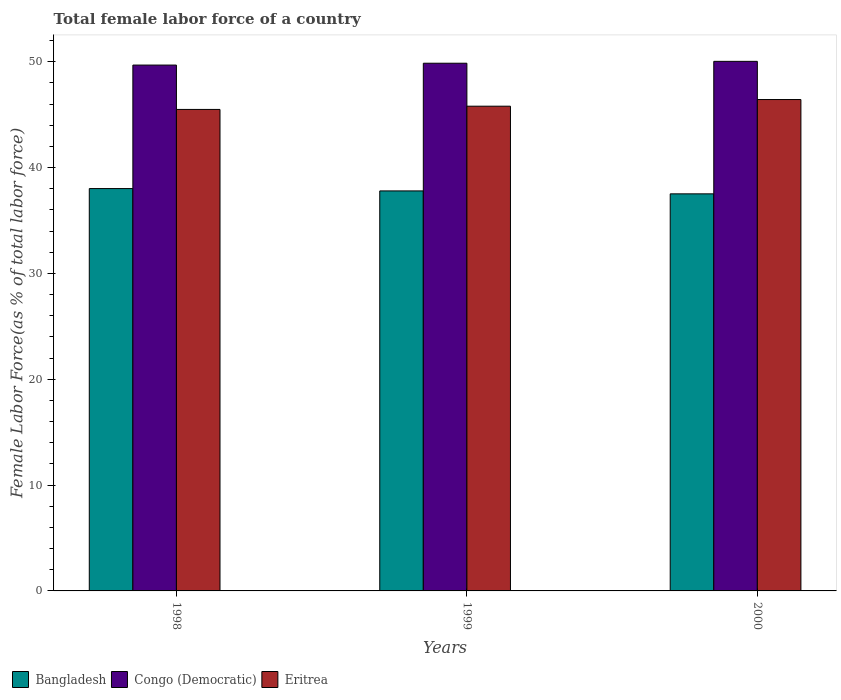How many different coloured bars are there?
Give a very brief answer. 3. How many groups of bars are there?
Give a very brief answer. 3. Are the number of bars on each tick of the X-axis equal?
Your response must be concise. Yes. How many bars are there on the 2nd tick from the right?
Provide a succinct answer. 3. What is the label of the 2nd group of bars from the left?
Provide a succinct answer. 1999. In how many cases, is the number of bars for a given year not equal to the number of legend labels?
Your answer should be compact. 0. What is the percentage of female labor force in Eritrea in 1999?
Your answer should be very brief. 45.81. Across all years, what is the maximum percentage of female labor force in Eritrea?
Offer a terse response. 46.44. Across all years, what is the minimum percentage of female labor force in Bangladesh?
Make the answer very short. 37.52. In which year was the percentage of female labor force in Bangladesh minimum?
Offer a terse response. 2000. What is the total percentage of female labor force in Bangladesh in the graph?
Your response must be concise. 113.35. What is the difference between the percentage of female labor force in Eritrea in 1998 and that in 1999?
Keep it short and to the point. -0.31. What is the difference between the percentage of female labor force in Congo (Democratic) in 1998 and the percentage of female labor force in Bangladesh in 1999?
Offer a very short reply. 11.89. What is the average percentage of female labor force in Bangladesh per year?
Your answer should be very brief. 37.78. In the year 2000, what is the difference between the percentage of female labor force in Congo (Democratic) and percentage of female labor force in Bangladesh?
Your answer should be compact. 12.52. What is the ratio of the percentage of female labor force in Bangladesh in 1998 to that in 2000?
Your answer should be very brief. 1.01. Is the difference between the percentage of female labor force in Congo (Democratic) in 1998 and 1999 greater than the difference between the percentage of female labor force in Bangladesh in 1998 and 1999?
Your answer should be compact. No. What is the difference between the highest and the second highest percentage of female labor force in Bangladesh?
Your response must be concise. 0.22. What is the difference between the highest and the lowest percentage of female labor force in Congo (Democratic)?
Ensure brevity in your answer.  0.35. Is it the case that in every year, the sum of the percentage of female labor force in Eritrea and percentage of female labor force in Bangladesh is greater than the percentage of female labor force in Congo (Democratic)?
Offer a terse response. Yes. How many bars are there?
Provide a short and direct response. 9. Are all the bars in the graph horizontal?
Offer a very short reply. No. How many years are there in the graph?
Ensure brevity in your answer.  3. What is the difference between two consecutive major ticks on the Y-axis?
Your answer should be compact. 10. Are the values on the major ticks of Y-axis written in scientific E-notation?
Your response must be concise. No. Does the graph contain grids?
Offer a very short reply. No. Where does the legend appear in the graph?
Your answer should be compact. Bottom left. What is the title of the graph?
Your response must be concise. Total female labor force of a country. What is the label or title of the Y-axis?
Offer a terse response. Female Labor Force(as % of total labor force). What is the Female Labor Force(as % of total labor force) in Bangladesh in 1998?
Ensure brevity in your answer.  38.02. What is the Female Labor Force(as % of total labor force) in Congo (Democratic) in 1998?
Ensure brevity in your answer.  49.69. What is the Female Labor Force(as % of total labor force) in Eritrea in 1998?
Your response must be concise. 45.5. What is the Female Labor Force(as % of total labor force) in Bangladesh in 1999?
Ensure brevity in your answer.  37.8. What is the Female Labor Force(as % of total labor force) of Congo (Democratic) in 1999?
Make the answer very short. 49.87. What is the Female Labor Force(as % of total labor force) in Eritrea in 1999?
Offer a very short reply. 45.81. What is the Female Labor Force(as % of total labor force) in Bangladesh in 2000?
Offer a terse response. 37.52. What is the Female Labor Force(as % of total labor force) in Congo (Democratic) in 2000?
Your answer should be compact. 50.05. What is the Female Labor Force(as % of total labor force) in Eritrea in 2000?
Give a very brief answer. 46.44. Across all years, what is the maximum Female Labor Force(as % of total labor force) of Bangladesh?
Ensure brevity in your answer.  38.02. Across all years, what is the maximum Female Labor Force(as % of total labor force) of Congo (Democratic)?
Your answer should be compact. 50.05. Across all years, what is the maximum Female Labor Force(as % of total labor force) of Eritrea?
Make the answer very short. 46.44. Across all years, what is the minimum Female Labor Force(as % of total labor force) in Bangladesh?
Make the answer very short. 37.52. Across all years, what is the minimum Female Labor Force(as % of total labor force) in Congo (Democratic)?
Provide a succinct answer. 49.69. Across all years, what is the minimum Female Labor Force(as % of total labor force) of Eritrea?
Provide a succinct answer. 45.5. What is the total Female Labor Force(as % of total labor force) in Bangladesh in the graph?
Provide a succinct answer. 113.35. What is the total Female Labor Force(as % of total labor force) of Congo (Democratic) in the graph?
Your answer should be very brief. 149.61. What is the total Female Labor Force(as % of total labor force) in Eritrea in the graph?
Make the answer very short. 137.75. What is the difference between the Female Labor Force(as % of total labor force) of Bangladesh in 1998 and that in 1999?
Your answer should be very brief. 0.22. What is the difference between the Female Labor Force(as % of total labor force) in Congo (Democratic) in 1998 and that in 1999?
Provide a succinct answer. -0.17. What is the difference between the Female Labor Force(as % of total labor force) of Eritrea in 1998 and that in 1999?
Offer a very short reply. -0.31. What is the difference between the Female Labor Force(as % of total labor force) in Bangladesh in 1998 and that in 2000?
Provide a succinct answer. 0.5. What is the difference between the Female Labor Force(as % of total labor force) of Congo (Democratic) in 1998 and that in 2000?
Offer a very short reply. -0.35. What is the difference between the Female Labor Force(as % of total labor force) in Eritrea in 1998 and that in 2000?
Your response must be concise. -0.94. What is the difference between the Female Labor Force(as % of total labor force) of Bangladesh in 1999 and that in 2000?
Make the answer very short. 0.28. What is the difference between the Female Labor Force(as % of total labor force) in Congo (Democratic) in 1999 and that in 2000?
Offer a very short reply. -0.18. What is the difference between the Female Labor Force(as % of total labor force) of Eritrea in 1999 and that in 2000?
Your answer should be very brief. -0.63. What is the difference between the Female Labor Force(as % of total labor force) in Bangladesh in 1998 and the Female Labor Force(as % of total labor force) in Congo (Democratic) in 1999?
Your answer should be compact. -11.85. What is the difference between the Female Labor Force(as % of total labor force) of Bangladesh in 1998 and the Female Labor Force(as % of total labor force) of Eritrea in 1999?
Ensure brevity in your answer.  -7.78. What is the difference between the Female Labor Force(as % of total labor force) in Congo (Democratic) in 1998 and the Female Labor Force(as % of total labor force) in Eritrea in 1999?
Ensure brevity in your answer.  3.89. What is the difference between the Female Labor Force(as % of total labor force) in Bangladesh in 1998 and the Female Labor Force(as % of total labor force) in Congo (Democratic) in 2000?
Your answer should be very brief. -12.02. What is the difference between the Female Labor Force(as % of total labor force) in Bangladesh in 1998 and the Female Labor Force(as % of total labor force) in Eritrea in 2000?
Ensure brevity in your answer.  -8.41. What is the difference between the Female Labor Force(as % of total labor force) of Congo (Democratic) in 1998 and the Female Labor Force(as % of total labor force) of Eritrea in 2000?
Give a very brief answer. 3.26. What is the difference between the Female Labor Force(as % of total labor force) in Bangladesh in 1999 and the Female Labor Force(as % of total labor force) in Congo (Democratic) in 2000?
Ensure brevity in your answer.  -12.24. What is the difference between the Female Labor Force(as % of total labor force) of Bangladesh in 1999 and the Female Labor Force(as % of total labor force) of Eritrea in 2000?
Your answer should be compact. -8.64. What is the difference between the Female Labor Force(as % of total labor force) in Congo (Democratic) in 1999 and the Female Labor Force(as % of total labor force) in Eritrea in 2000?
Ensure brevity in your answer.  3.43. What is the average Female Labor Force(as % of total labor force) of Bangladesh per year?
Provide a short and direct response. 37.78. What is the average Female Labor Force(as % of total labor force) in Congo (Democratic) per year?
Your answer should be compact. 49.87. What is the average Female Labor Force(as % of total labor force) of Eritrea per year?
Provide a succinct answer. 45.92. In the year 1998, what is the difference between the Female Labor Force(as % of total labor force) in Bangladesh and Female Labor Force(as % of total labor force) in Congo (Democratic)?
Give a very brief answer. -11.67. In the year 1998, what is the difference between the Female Labor Force(as % of total labor force) in Bangladesh and Female Labor Force(as % of total labor force) in Eritrea?
Your answer should be very brief. -7.48. In the year 1998, what is the difference between the Female Labor Force(as % of total labor force) of Congo (Democratic) and Female Labor Force(as % of total labor force) of Eritrea?
Offer a terse response. 4.19. In the year 1999, what is the difference between the Female Labor Force(as % of total labor force) of Bangladesh and Female Labor Force(as % of total labor force) of Congo (Democratic)?
Provide a short and direct response. -12.07. In the year 1999, what is the difference between the Female Labor Force(as % of total labor force) in Bangladesh and Female Labor Force(as % of total labor force) in Eritrea?
Your answer should be very brief. -8.01. In the year 1999, what is the difference between the Female Labor Force(as % of total labor force) of Congo (Democratic) and Female Labor Force(as % of total labor force) of Eritrea?
Ensure brevity in your answer.  4.06. In the year 2000, what is the difference between the Female Labor Force(as % of total labor force) in Bangladesh and Female Labor Force(as % of total labor force) in Congo (Democratic)?
Give a very brief answer. -12.52. In the year 2000, what is the difference between the Female Labor Force(as % of total labor force) in Bangladesh and Female Labor Force(as % of total labor force) in Eritrea?
Ensure brevity in your answer.  -8.91. In the year 2000, what is the difference between the Female Labor Force(as % of total labor force) in Congo (Democratic) and Female Labor Force(as % of total labor force) in Eritrea?
Your response must be concise. 3.61. What is the ratio of the Female Labor Force(as % of total labor force) in Bangladesh in 1998 to that in 1999?
Make the answer very short. 1.01. What is the ratio of the Female Labor Force(as % of total labor force) in Bangladesh in 1998 to that in 2000?
Your answer should be compact. 1.01. What is the ratio of the Female Labor Force(as % of total labor force) of Eritrea in 1998 to that in 2000?
Offer a very short reply. 0.98. What is the ratio of the Female Labor Force(as % of total labor force) of Bangladesh in 1999 to that in 2000?
Give a very brief answer. 1.01. What is the ratio of the Female Labor Force(as % of total labor force) of Congo (Democratic) in 1999 to that in 2000?
Give a very brief answer. 1. What is the ratio of the Female Labor Force(as % of total labor force) in Eritrea in 1999 to that in 2000?
Provide a short and direct response. 0.99. What is the difference between the highest and the second highest Female Labor Force(as % of total labor force) of Bangladesh?
Make the answer very short. 0.22. What is the difference between the highest and the second highest Female Labor Force(as % of total labor force) in Congo (Democratic)?
Provide a short and direct response. 0.18. What is the difference between the highest and the second highest Female Labor Force(as % of total labor force) in Eritrea?
Your answer should be compact. 0.63. What is the difference between the highest and the lowest Female Labor Force(as % of total labor force) of Bangladesh?
Your response must be concise. 0.5. What is the difference between the highest and the lowest Female Labor Force(as % of total labor force) in Congo (Democratic)?
Your response must be concise. 0.35. What is the difference between the highest and the lowest Female Labor Force(as % of total labor force) in Eritrea?
Offer a terse response. 0.94. 